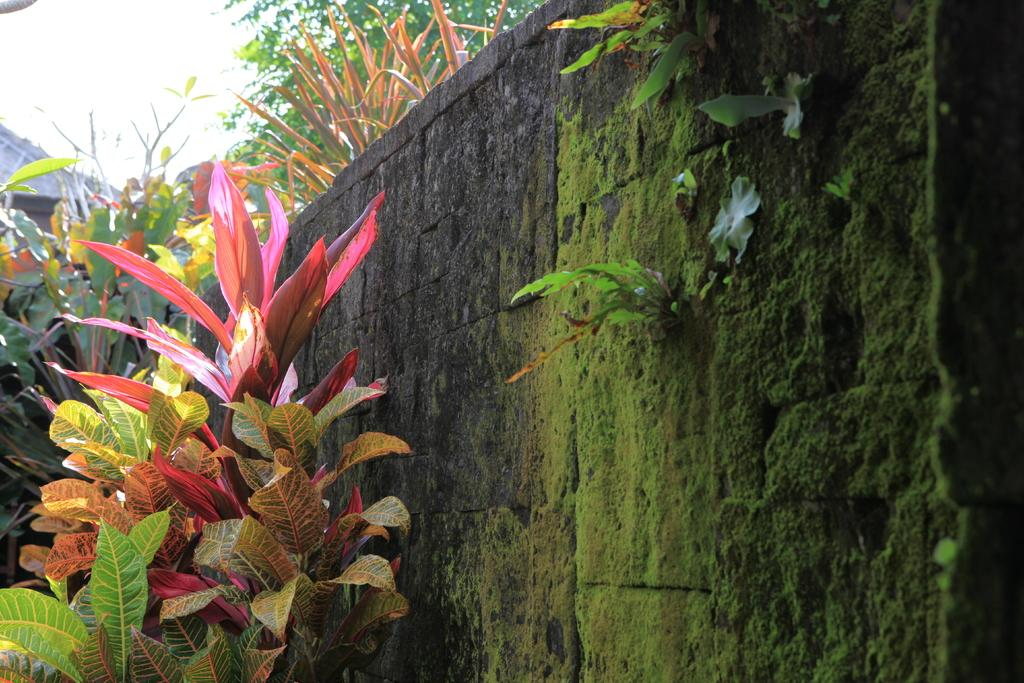What is on the wall in the image? There is algae on the wall in the image. What type of vegetation can be seen in the image? There are plants and trees in the image. What can be seen in the sky in the image? The sky is visible in the image. What is the opinion of the drum on the parcel in the image? There is no drum or parcel present in the image, so it is not possible to determine any opinions. 